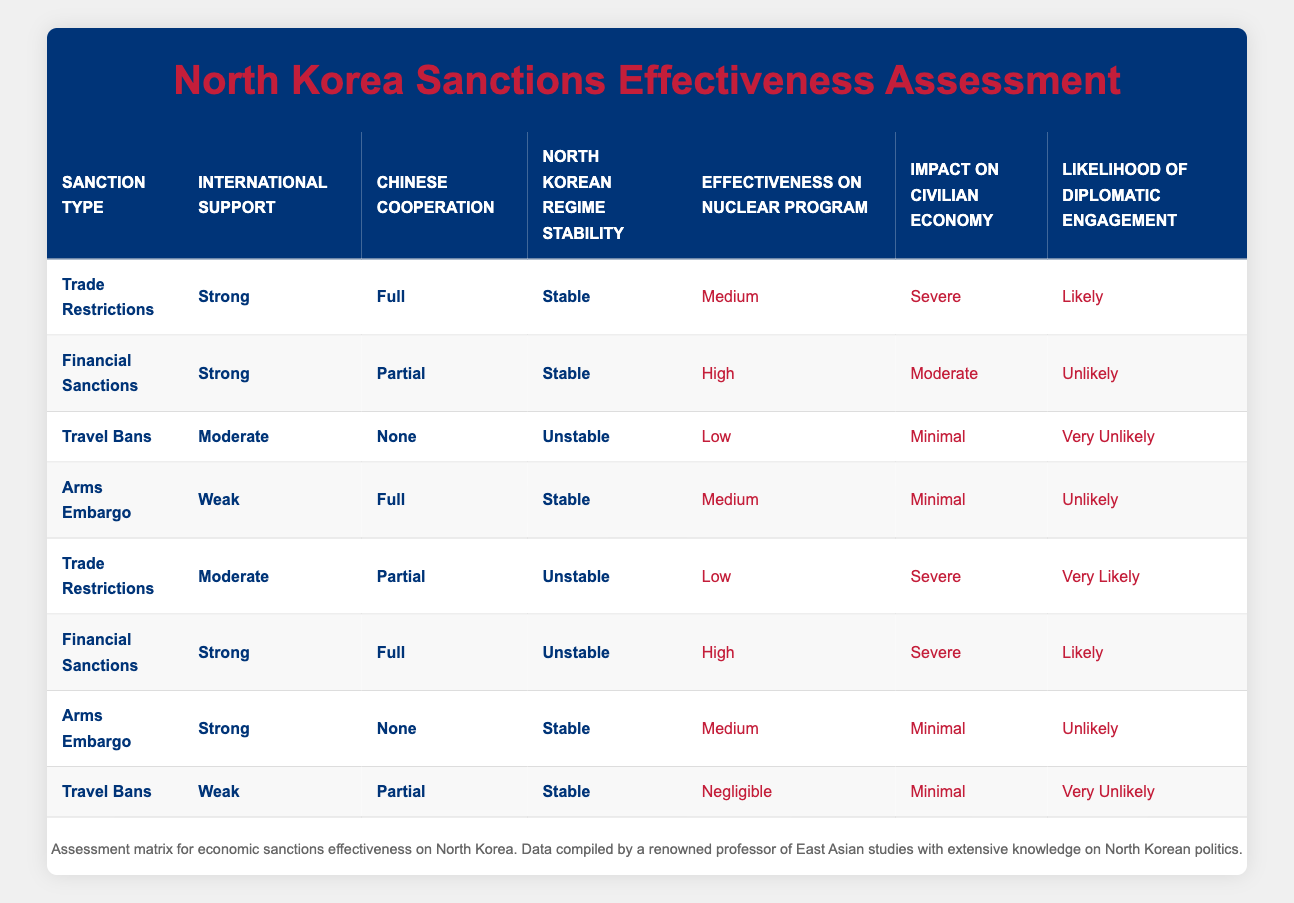What type of sanctions has the highest likelihood of diplomatic engagement? By reviewing the 'Likelihood of Diplomatic Engagement' column, we see that the 'Trade Restrictions' under 'Moderate' support with 'Unstable' stability indicates 'Very Likely.' This is the highest likelihood category noted in the table.
Answer: Trade Restrictions What is the impact on the civilian economy if 'Financial Sanctions' are applied with 'Strong' international support and 'Partial' Chinese cooperation? Checking the 'Impact on Civilian Economy' column corresponding to 'Financial Sanctions', 'Strong' support, and 'Partial' cooperation shows 'Moderate' impact on the civilian economy.
Answer: Moderate Is there any scenario where 'Travel Bans' can have a high effectiveness on the nuclear program? Looking through the table, the 'Effectiveness on Nuclear Program' for 'Travel Bans' is only noted as 'Low' or 'Negligible' in all rows, thus indicating that there is no scenario with high effectiveness.
Answer: No What is the average effectiveness on the nuclear program across all scenarios listed for 'Trade Restrictions'? There are two entries for 'Trade Restrictions': one with 'Medium' and another with 'Low' effectiveness. Assigning numerical values (High=3, Medium=2, Low=1), we get (2 + 1) / 2 = 1.5, which is equivalent to 'Medium' effectiveness.
Answer: Medium For 'Arms Embargo' with 'Strong' support and 'None' cooperation, what is the effectiveness on the nuclear program? Checking the row for 'Arms Embargo,' 'Strong' support, and 'None' cooperation, we see the 'Effectiveness on Nuclear Program' is categorized as 'Medium.'
Answer: Medium What impact does applying 'Trade Restrictions' with 'Strong' support and 'Full' Chinese cooperation have on the civilian economy? In the corresponding row of the table for 'Trade Restrictions,' 'Strong' support, and 'Full' cooperation, we see the 'Impact on Civilian Economy' rated as 'Severe.'
Answer: Severe What sanction type displayed the lowest effectiveness on the nuclear program? By examining the 'Effectiveness on Nuclear Program' column, we find that both 'Travel Bans' and 'Financial Sanctions' with certain conditions indicate 'Low' or 'Negligible' effectiveness. However, 'Travel Bans' show the lowest values of 'Negligible.'
Answer: Travel Bans Does any row indicate that 'Chinese Cooperation' is 'None' and still leads to a likely diplomatic engagement? Upon reviewing the table, no entries where 'Chinese Cooperation' is 'None' show a 'Likely' diplomatic engagement; rather, it remains 'Very Unlikely' or 'Unlikely.'
Answer: No 